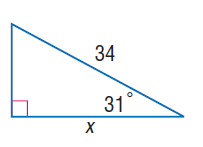Answer the mathemtical geometry problem and directly provide the correct option letter.
Question: Find x.
Choices: A: 7.3 B: 25.8 C: 29.1 D: 33.4 C 